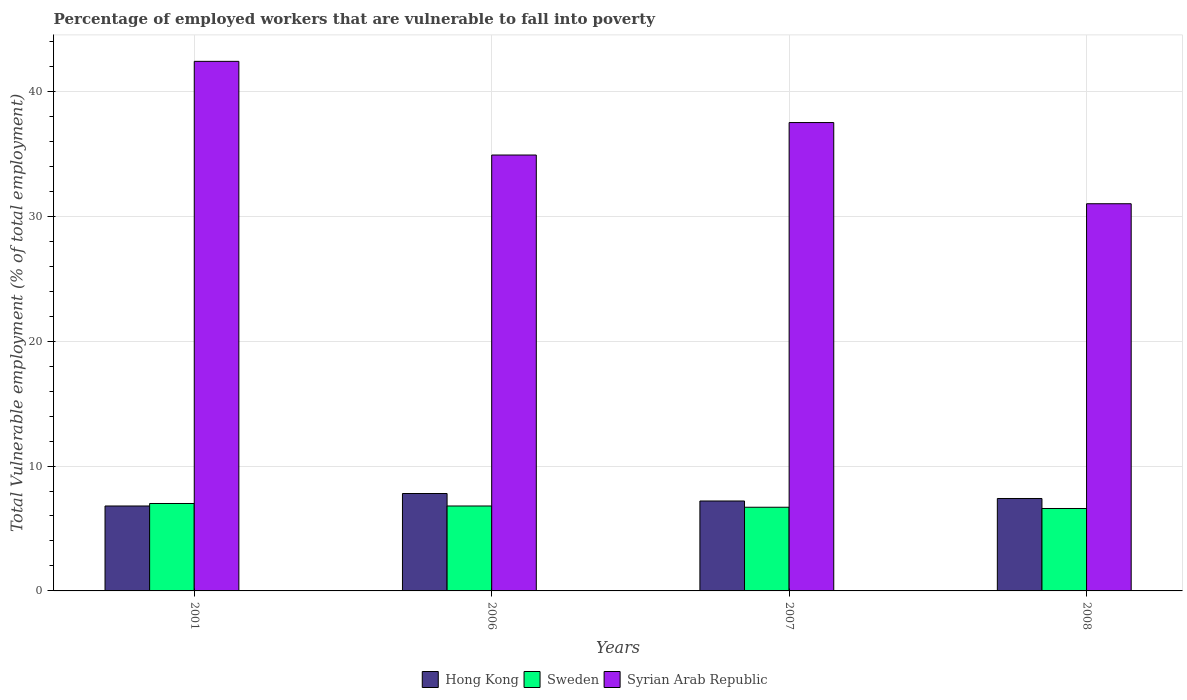How many different coloured bars are there?
Your response must be concise. 3. How many bars are there on the 2nd tick from the right?
Make the answer very short. 3. In how many cases, is the number of bars for a given year not equal to the number of legend labels?
Provide a succinct answer. 0. What is the percentage of employed workers who are vulnerable to fall into poverty in Syrian Arab Republic in 2008?
Offer a terse response. 31. Across all years, what is the maximum percentage of employed workers who are vulnerable to fall into poverty in Syrian Arab Republic?
Give a very brief answer. 42.4. Across all years, what is the minimum percentage of employed workers who are vulnerable to fall into poverty in Sweden?
Provide a short and direct response. 6.6. In which year was the percentage of employed workers who are vulnerable to fall into poverty in Syrian Arab Republic maximum?
Give a very brief answer. 2001. What is the total percentage of employed workers who are vulnerable to fall into poverty in Hong Kong in the graph?
Offer a terse response. 29.2. What is the difference between the percentage of employed workers who are vulnerable to fall into poverty in Syrian Arab Republic in 2001 and that in 2008?
Keep it short and to the point. 11.4. What is the difference between the percentage of employed workers who are vulnerable to fall into poverty in Sweden in 2008 and the percentage of employed workers who are vulnerable to fall into poverty in Syrian Arab Republic in 2001?
Your response must be concise. -35.8. What is the average percentage of employed workers who are vulnerable to fall into poverty in Sweden per year?
Offer a very short reply. 6.77. In the year 2001, what is the difference between the percentage of employed workers who are vulnerable to fall into poverty in Syrian Arab Republic and percentage of employed workers who are vulnerable to fall into poverty in Sweden?
Your answer should be very brief. 35.4. In how many years, is the percentage of employed workers who are vulnerable to fall into poverty in Syrian Arab Republic greater than 22 %?
Keep it short and to the point. 4. What is the ratio of the percentage of employed workers who are vulnerable to fall into poverty in Syrian Arab Republic in 2006 to that in 2007?
Provide a succinct answer. 0.93. Is the percentage of employed workers who are vulnerable to fall into poverty in Sweden in 2001 less than that in 2008?
Your answer should be compact. No. What is the difference between the highest and the second highest percentage of employed workers who are vulnerable to fall into poverty in Sweden?
Provide a short and direct response. 0.2. In how many years, is the percentage of employed workers who are vulnerable to fall into poverty in Syrian Arab Republic greater than the average percentage of employed workers who are vulnerable to fall into poverty in Syrian Arab Republic taken over all years?
Provide a succinct answer. 2. What does the 1st bar from the left in 2008 represents?
Your answer should be compact. Hong Kong. What does the 2nd bar from the right in 2008 represents?
Ensure brevity in your answer.  Sweden. How many bars are there?
Offer a terse response. 12. What is the difference between two consecutive major ticks on the Y-axis?
Provide a succinct answer. 10. Are the values on the major ticks of Y-axis written in scientific E-notation?
Your answer should be very brief. No. Does the graph contain any zero values?
Offer a terse response. No. Does the graph contain grids?
Provide a succinct answer. Yes. How are the legend labels stacked?
Offer a very short reply. Horizontal. What is the title of the graph?
Ensure brevity in your answer.  Percentage of employed workers that are vulnerable to fall into poverty. What is the label or title of the X-axis?
Give a very brief answer. Years. What is the label or title of the Y-axis?
Provide a succinct answer. Total Vulnerable employment (% of total employment). What is the Total Vulnerable employment (% of total employment) of Hong Kong in 2001?
Your response must be concise. 6.8. What is the Total Vulnerable employment (% of total employment) of Sweden in 2001?
Offer a very short reply. 7. What is the Total Vulnerable employment (% of total employment) in Syrian Arab Republic in 2001?
Your response must be concise. 42.4. What is the Total Vulnerable employment (% of total employment) of Hong Kong in 2006?
Give a very brief answer. 7.8. What is the Total Vulnerable employment (% of total employment) of Sweden in 2006?
Offer a very short reply. 6.8. What is the Total Vulnerable employment (% of total employment) in Syrian Arab Republic in 2006?
Ensure brevity in your answer.  34.9. What is the Total Vulnerable employment (% of total employment) in Hong Kong in 2007?
Offer a terse response. 7.2. What is the Total Vulnerable employment (% of total employment) of Sweden in 2007?
Give a very brief answer. 6.7. What is the Total Vulnerable employment (% of total employment) in Syrian Arab Republic in 2007?
Keep it short and to the point. 37.5. What is the Total Vulnerable employment (% of total employment) of Hong Kong in 2008?
Offer a terse response. 7.4. What is the Total Vulnerable employment (% of total employment) in Sweden in 2008?
Provide a short and direct response. 6.6. Across all years, what is the maximum Total Vulnerable employment (% of total employment) of Hong Kong?
Give a very brief answer. 7.8. Across all years, what is the maximum Total Vulnerable employment (% of total employment) in Sweden?
Your answer should be compact. 7. Across all years, what is the maximum Total Vulnerable employment (% of total employment) of Syrian Arab Republic?
Make the answer very short. 42.4. Across all years, what is the minimum Total Vulnerable employment (% of total employment) in Hong Kong?
Offer a very short reply. 6.8. Across all years, what is the minimum Total Vulnerable employment (% of total employment) in Sweden?
Offer a very short reply. 6.6. What is the total Total Vulnerable employment (% of total employment) in Hong Kong in the graph?
Offer a very short reply. 29.2. What is the total Total Vulnerable employment (% of total employment) of Sweden in the graph?
Your response must be concise. 27.1. What is the total Total Vulnerable employment (% of total employment) in Syrian Arab Republic in the graph?
Your answer should be compact. 145.8. What is the difference between the Total Vulnerable employment (% of total employment) in Hong Kong in 2001 and that in 2006?
Your answer should be compact. -1. What is the difference between the Total Vulnerable employment (% of total employment) in Sweden in 2001 and that in 2006?
Offer a very short reply. 0.2. What is the difference between the Total Vulnerable employment (% of total employment) in Syrian Arab Republic in 2001 and that in 2006?
Give a very brief answer. 7.5. What is the difference between the Total Vulnerable employment (% of total employment) in Sweden in 2001 and that in 2007?
Make the answer very short. 0.3. What is the difference between the Total Vulnerable employment (% of total employment) of Syrian Arab Republic in 2001 and that in 2007?
Make the answer very short. 4.9. What is the difference between the Total Vulnerable employment (% of total employment) in Hong Kong in 2001 and that in 2008?
Your response must be concise. -0.6. What is the difference between the Total Vulnerable employment (% of total employment) in Sweden in 2001 and that in 2008?
Keep it short and to the point. 0.4. What is the difference between the Total Vulnerable employment (% of total employment) in Syrian Arab Republic in 2001 and that in 2008?
Keep it short and to the point. 11.4. What is the difference between the Total Vulnerable employment (% of total employment) in Sweden in 2007 and that in 2008?
Ensure brevity in your answer.  0.1. What is the difference between the Total Vulnerable employment (% of total employment) of Hong Kong in 2001 and the Total Vulnerable employment (% of total employment) of Sweden in 2006?
Offer a terse response. 0. What is the difference between the Total Vulnerable employment (% of total employment) of Hong Kong in 2001 and the Total Vulnerable employment (% of total employment) of Syrian Arab Republic in 2006?
Your answer should be very brief. -28.1. What is the difference between the Total Vulnerable employment (% of total employment) in Sweden in 2001 and the Total Vulnerable employment (% of total employment) in Syrian Arab Republic in 2006?
Your answer should be very brief. -27.9. What is the difference between the Total Vulnerable employment (% of total employment) of Hong Kong in 2001 and the Total Vulnerable employment (% of total employment) of Sweden in 2007?
Offer a very short reply. 0.1. What is the difference between the Total Vulnerable employment (% of total employment) of Hong Kong in 2001 and the Total Vulnerable employment (% of total employment) of Syrian Arab Republic in 2007?
Offer a terse response. -30.7. What is the difference between the Total Vulnerable employment (% of total employment) in Sweden in 2001 and the Total Vulnerable employment (% of total employment) in Syrian Arab Republic in 2007?
Offer a terse response. -30.5. What is the difference between the Total Vulnerable employment (% of total employment) of Hong Kong in 2001 and the Total Vulnerable employment (% of total employment) of Sweden in 2008?
Ensure brevity in your answer.  0.2. What is the difference between the Total Vulnerable employment (% of total employment) of Hong Kong in 2001 and the Total Vulnerable employment (% of total employment) of Syrian Arab Republic in 2008?
Offer a terse response. -24.2. What is the difference between the Total Vulnerable employment (% of total employment) in Hong Kong in 2006 and the Total Vulnerable employment (% of total employment) in Syrian Arab Republic in 2007?
Make the answer very short. -29.7. What is the difference between the Total Vulnerable employment (% of total employment) of Sweden in 2006 and the Total Vulnerable employment (% of total employment) of Syrian Arab Republic in 2007?
Offer a very short reply. -30.7. What is the difference between the Total Vulnerable employment (% of total employment) of Hong Kong in 2006 and the Total Vulnerable employment (% of total employment) of Syrian Arab Republic in 2008?
Your response must be concise. -23.2. What is the difference between the Total Vulnerable employment (% of total employment) of Sweden in 2006 and the Total Vulnerable employment (% of total employment) of Syrian Arab Republic in 2008?
Ensure brevity in your answer.  -24.2. What is the difference between the Total Vulnerable employment (% of total employment) in Hong Kong in 2007 and the Total Vulnerable employment (% of total employment) in Syrian Arab Republic in 2008?
Your answer should be very brief. -23.8. What is the difference between the Total Vulnerable employment (% of total employment) in Sweden in 2007 and the Total Vulnerable employment (% of total employment) in Syrian Arab Republic in 2008?
Your answer should be compact. -24.3. What is the average Total Vulnerable employment (% of total employment) in Sweden per year?
Your response must be concise. 6.78. What is the average Total Vulnerable employment (% of total employment) of Syrian Arab Republic per year?
Ensure brevity in your answer.  36.45. In the year 2001, what is the difference between the Total Vulnerable employment (% of total employment) in Hong Kong and Total Vulnerable employment (% of total employment) in Sweden?
Provide a short and direct response. -0.2. In the year 2001, what is the difference between the Total Vulnerable employment (% of total employment) of Hong Kong and Total Vulnerable employment (% of total employment) of Syrian Arab Republic?
Your answer should be very brief. -35.6. In the year 2001, what is the difference between the Total Vulnerable employment (% of total employment) in Sweden and Total Vulnerable employment (% of total employment) in Syrian Arab Republic?
Offer a terse response. -35.4. In the year 2006, what is the difference between the Total Vulnerable employment (% of total employment) in Hong Kong and Total Vulnerable employment (% of total employment) in Syrian Arab Republic?
Provide a short and direct response. -27.1. In the year 2006, what is the difference between the Total Vulnerable employment (% of total employment) of Sweden and Total Vulnerable employment (% of total employment) of Syrian Arab Republic?
Your response must be concise. -28.1. In the year 2007, what is the difference between the Total Vulnerable employment (% of total employment) of Hong Kong and Total Vulnerable employment (% of total employment) of Sweden?
Make the answer very short. 0.5. In the year 2007, what is the difference between the Total Vulnerable employment (% of total employment) in Hong Kong and Total Vulnerable employment (% of total employment) in Syrian Arab Republic?
Ensure brevity in your answer.  -30.3. In the year 2007, what is the difference between the Total Vulnerable employment (% of total employment) of Sweden and Total Vulnerable employment (% of total employment) of Syrian Arab Republic?
Give a very brief answer. -30.8. In the year 2008, what is the difference between the Total Vulnerable employment (% of total employment) in Hong Kong and Total Vulnerable employment (% of total employment) in Sweden?
Your answer should be compact. 0.8. In the year 2008, what is the difference between the Total Vulnerable employment (% of total employment) in Hong Kong and Total Vulnerable employment (% of total employment) in Syrian Arab Republic?
Ensure brevity in your answer.  -23.6. In the year 2008, what is the difference between the Total Vulnerable employment (% of total employment) of Sweden and Total Vulnerable employment (% of total employment) of Syrian Arab Republic?
Your answer should be compact. -24.4. What is the ratio of the Total Vulnerable employment (% of total employment) in Hong Kong in 2001 to that in 2006?
Your answer should be compact. 0.87. What is the ratio of the Total Vulnerable employment (% of total employment) in Sweden in 2001 to that in 2006?
Your response must be concise. 1.03. What is the ratio of the Total Vulnerable employment (% of total employment) of Syrian Arab Republic in 2001 to that in 2006?
Your answer should be compact. 1.21. What is the ratio of the Total Vulnerable employment (% of total employment) of Sweden in 2001 to that in 2007?
Give a very brief answer. 1.04. What is the ratio of the Total Vulnerable employment (% of total employment) in Syrian Arab Republic in 2001 to that in 2007?
Provide a succinct answer. 1.13. What is the ratio of the Total Vulnerable employment (% of total employment) in Hong Kong in 2001 to that in 2008?
Make the answer very short. 0.92. What is the ratio of the Total Vulnerable employment (% of total employment) of Sweden in 2001 to that in 2008?
Your response must be concise. 1.06. What is the ratio of the Total Vulnerable employment (% of total employment) in Syrian Arab Republic in 2001 to that in 2008?
Your answer should be very brief. 1.37. What is the ratio of the Total Vulnerable employment (% of total employment) in Hong Kong in 2006 to that in 2007?
Make the answer very short. 1.08. What is the ratio of the Total Vulnerable employment (% of total employment) in Sweden in 2006 to that in 2007?
Your answer should be very brief. 1.01. What is the ratio of the Total Vulnerable employment (% of total employment) of Syrian Arab Republic in 2006 to that in 2007?
Ensure brevity in your answer.  0.93. What is the ratio of the Total Vulnerable employment (% of total employment) in Hong Kong in 2006 to that in 2008?
Your response must be concise. 1.05. What is the ratio of the Total Vulnerable employment (% of total employment) in Sweden in 2006 to that in 2008?
Your answer should be compact. 1.03. What is the ratio of the Total Vulnerable employment (% of total employment) of Syrian Arab Republic in 2006 to that in 2008?
Offer a terse response. 1.13. What is the ratio of the Total Vulnerable employment (% of total employment) of Sweden in 2007 to that in 2008?
Offer a very short reply. 1.02. What is the ratio of the Total Vulnerable employment (% of total employment) of Syrian Arab Republic in 2007 to that in 2008?
Provide a short and direct response. 1.21. What is the difference between the highest and the second highest Total Vulnerable employment (% of total employment) in Hong Kong?
Keep it short and to the point. 0.4. What is the difference between the highest and the second highest Total Vulnerable employment (% of total employment) of Sweden?
Provide a short and direct response. 0.2. What is the difference between the highest and the second highest Total Vulnerable employment (% of total employment) of Syrian Arab Republic?
Your answer should be very brief. 4.9. What is the difference between the highest and the lowest Total Vulnerable employment (% of total employment) of Hong Kong?
Offer a very short reply. 1. What is the difference between the highest and the lowest Total Vulnerable employment (% of total employment) of Sweden?
Ensure brevity in your answer.  0.4. What is the difference between the highest and the lowest Total Vulnerable employment (% of total employment) in Syrian Arab Republic?
Offer a very short reply. 11.4. 